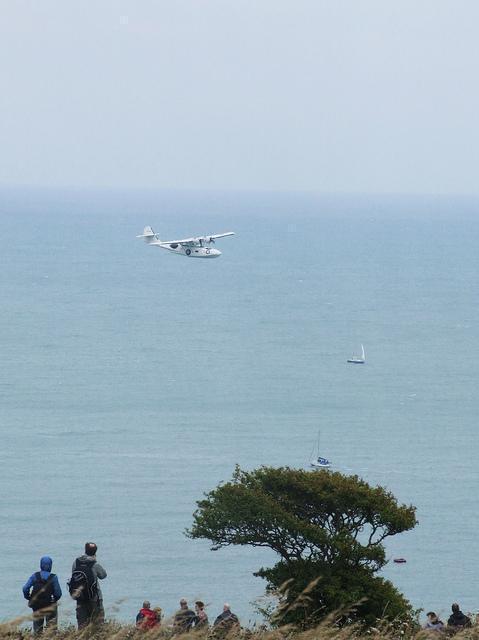Which thing here is the highest?
Indicate the correct response by choosing from the four available options to answer the question.
Options: Train, boat, airplane, car. Airplane. 